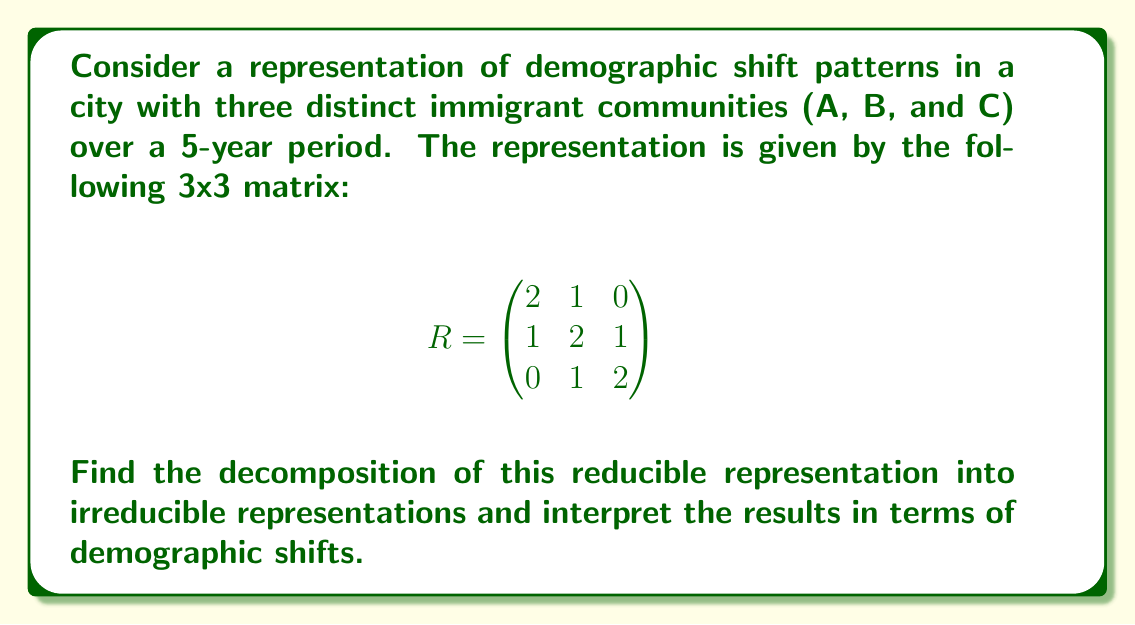Help me with this question. 1) First, we need to find the eigenvalues of the matrix $R$. The characteristic equation is:

   $$\det(R - \lambda I) = \begin{vmatrix}
   2-\lambda & 1 & 0 \\
   1 & 2-\lambda & 1 \\
   0 & 1 & 2-\lambda
   \end{vmatrix} = 0$$

2) Expanding this determinant:
   $$(2-\lambda)((2-\lambda)^2 - 1) - 1(1-0) = 0$$
   $$(2-\lambda)(4-4\lambda+\lambda^2 - 1) - 1 = 0$$
   $$(2-\lambda)(3-4\lambda+\lambda^2) - 1 = 0$$
   $$6-12\lambda+3\lambda^2-8\lambda+16\lambda^2-4\lambda^3 - 1 = 0$$
   $$-4\lambda^3 + 19\lambda^2 - 20\lambda + 5 = 0$$

3) The roots of this equation are $\lambda_1 = 1$, $\lambda_2 = 2$, and $\lambda_3 = 4$.

4) Each eigenvalue corresponds to an irreducible representation. The dimension of each irreducible representation is equal to the multiplicity of the corresponding eigenvalue.

5) Therefore, the decomposition is:
   $$R = 1 \oplus 2 \oplus 4$$

6) Interpretation:
   - The 1-dimensional representation ($\lambda_1 = 1$) indicates a stable component in the demographic shift.
   - The 1-dimensional representation ($\lambda_2 = 2$) suggests a moderate growth component.
   - The 1-dimensional representation ($\lambda_3 = 4$) indicates a rapid growth component.

These components affect the three immigrant communities (A, B, C) in different proportions, as indicated by the eigenvectors (not calculated here).
Answer: $R = 1 \oplus 2 \oplus 4$ 